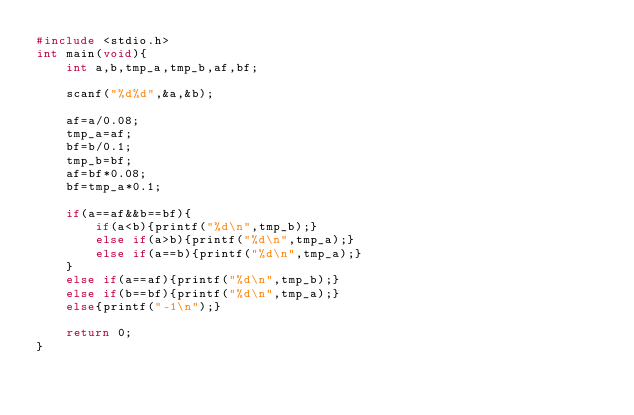Convert code to text. <code><loc_0><loc_0><loc_500><loc_500><_C_>#include <stdio.h>
int main(void){
    int a,b,tmp_a,tmp_b,af,bf;
    
    scanf("%d%d",&a,&b);
    
    af=a/0.08;
    tmp_a=af;
    bf=b/0.1;
    tmp_b=bf;
    af=bf*0.08;
    bf=tmp_a*0.1;

    if(a==af&&b==bf){
        if(a<b){printf("%d\n",tmp_b);}
        else if(a>b){printf("%d\n",tmp_a);}
        else if(a==b){printf("%d\n",tmp_a);}
    }
    else if(a==af){printf("%d\n",tmp_b);}
    else if(b==bf){printf("%d\n",tmp_a);}
    else{printf("-1\n");}
    
    return 0;
}
</code> 